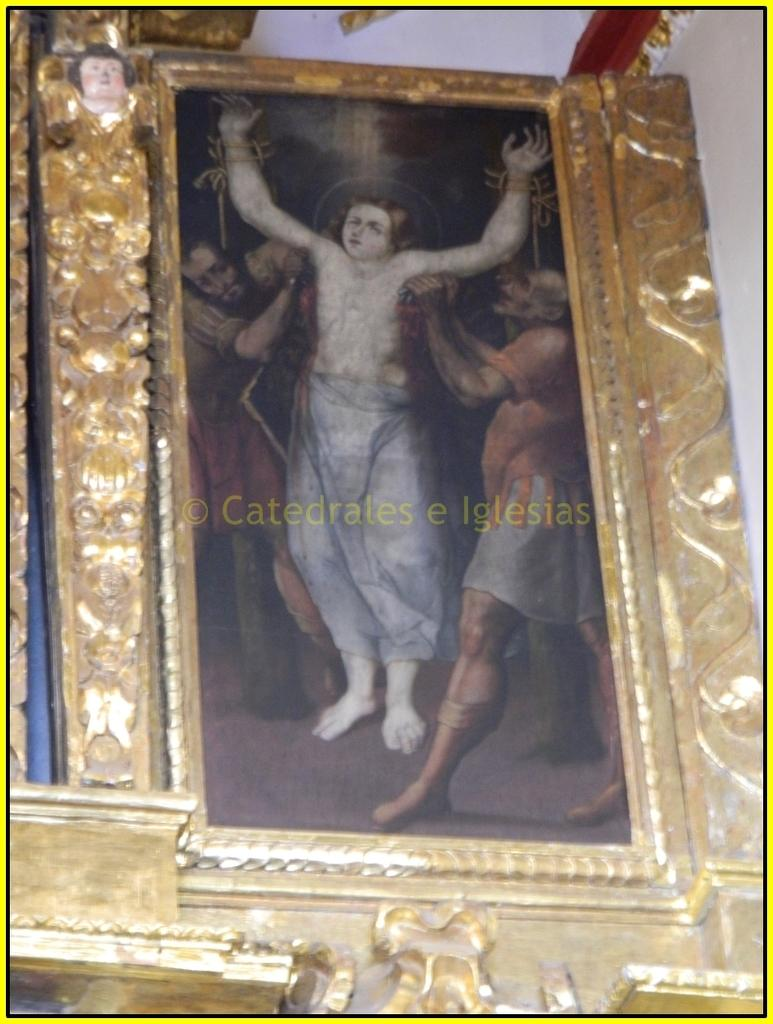What object is present in the image that typically holds a photograph? There is a photo frame in the image. What is the color or material of the frame surrounding the photo? The photo frame has a golden frame. Is there any additional mark or design in the center of the image? Yes, there is a watermark in the center of the image. What type of bone can be seen in the photo frame in the image? There is no bone present in the image; it features a photo frame with a golden frame and a watermark. Are there any toys visible in the photo frame in the image? There are no toys present in the image; it features a photo frame with a golden frame and a watermark. 